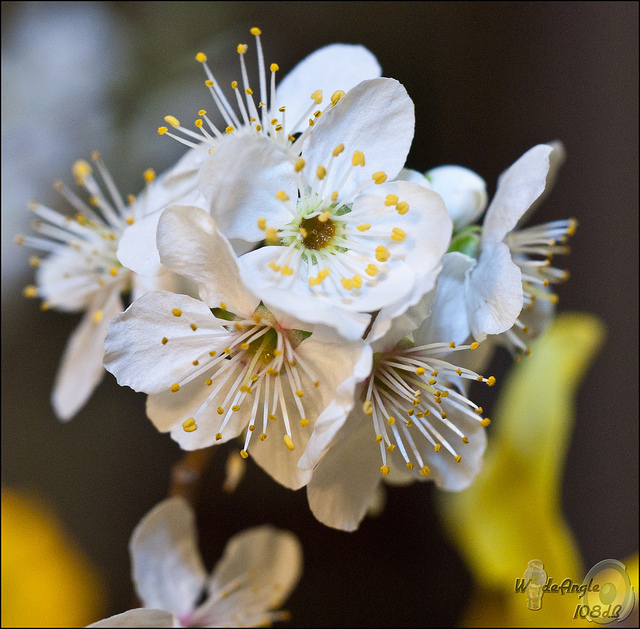<image>What type of flower is pictured? It's ambiguous to say which type of flower is pictured. It could be a daisy, freesia, poppy, lily, hydrangea, iris, or orchard. What type of flower is pictured? I am not sure what type of flower is pictured. It could be 'daisy', 'freesia', 'poppy', 'lily', 'hydrangea', 'white', 'lily', 'iris', or 'orchard'. 